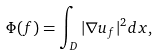Convert formula to latex. <formula><loc_0><loc_0><loc_500><loc_500>\Phi ( f ) = \int _ { D } | \nabla u _ { f } | ^ { 2 } d x ,</formula> 